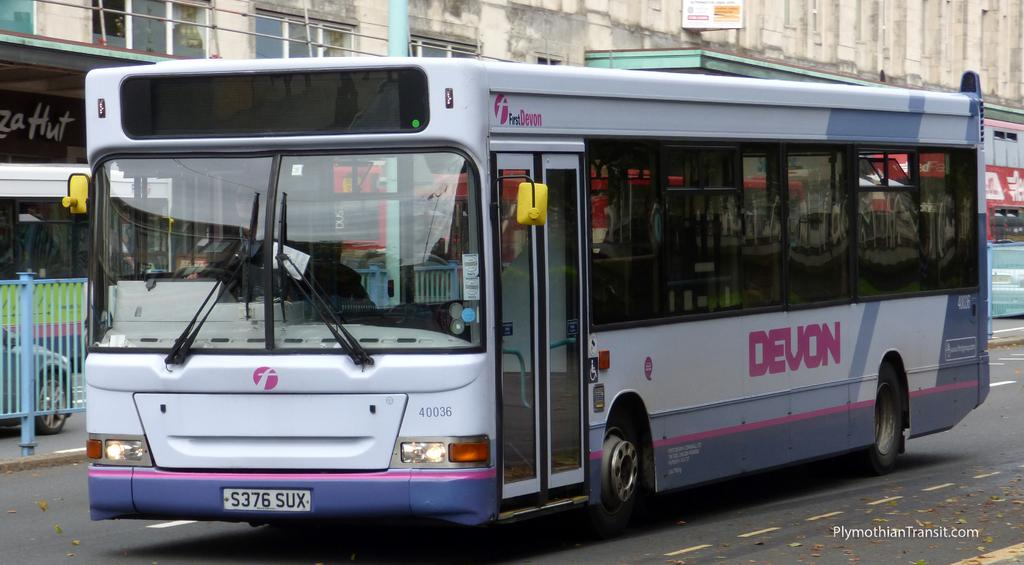Provide a one-sentence caption for the provided image. A white and purple Devon bus is going down a city street. 